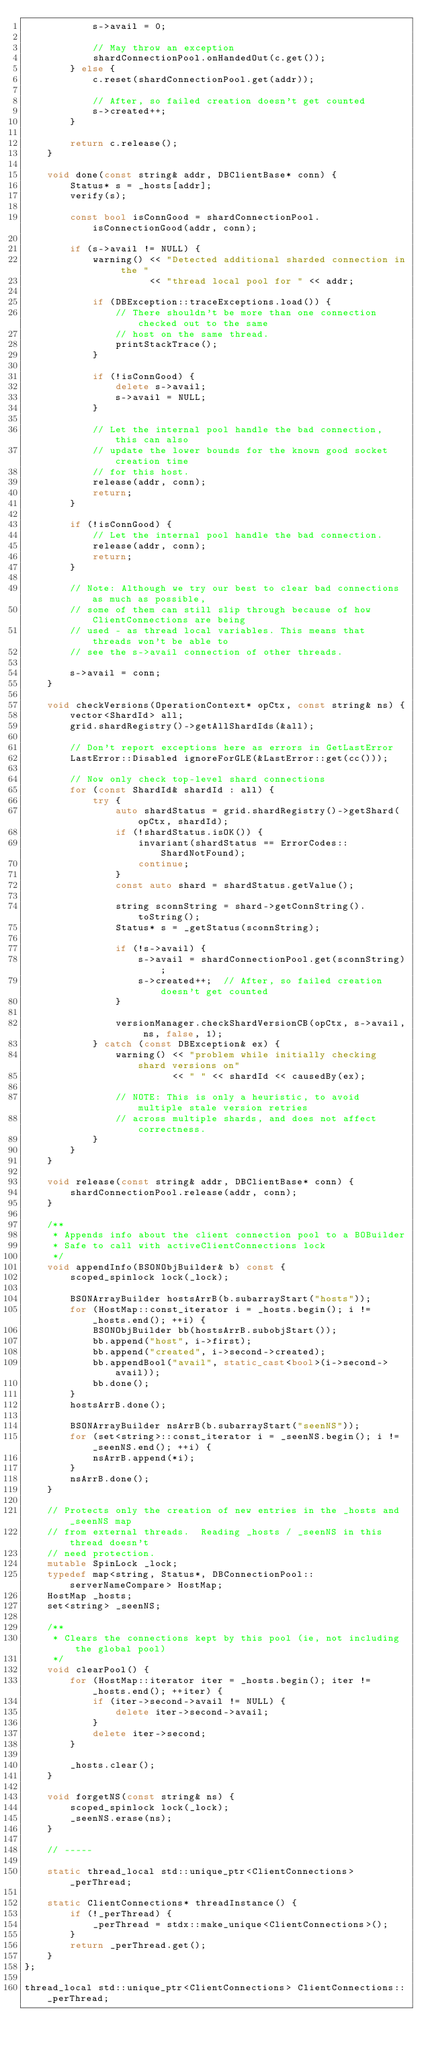Convert code to text. <code><loc_0><loc_0><loc_500><loc_500><_C++_>            s->avail = 0;

            // May throw an exception
            shardConnectionPool.onHandedOut(c.get());
        } else {
            c.reset(shardConnectionPool.get(addr));

            // After, so failed creation doesn't get counted
            s->created++;
        }

        return c.release();
    }

    void done(const string& addr, DBClientBase* conn) {
        Status* s = _hosts[addr];
        verify(s);

        const bool isConnGood = shardConnectionPool.isConnectionGood(addr, conn);

        if (s->avail != NULL) {
            warning() << "Detected additional sharded connection in the "
                      << "thread local pool for " << addr;

            if (DBException::traceExceptions.load()) {
                // There shouldn't be more than one connection checked out to the same
                // host on the same thread.
                printStackTrace();
            }

            if (!isConnGood) {
                delete s->avail;
                s->avail = NULL;
            }

            // Let the internal pool handle the bad connection, this can also
            // update the lower bounds for the known good socket creation time
            // for this host.
            release(addr, conn);
            return;
        }

        if (!isConnGood) {
            // Let the internal pool handle the bad connection.
            release(addr, conn);
            return;
        }

        // Note: Although we try our best to clear bad connections as much as possible,
        // some of them can still slip through because of how ClientConnections are being
        // used - as thread local variables. This means that threads won't be able to
        // see the s->avail connection of other threads.

        s->avail = conn;
    }

    void checkVersions(OperationContext* opCtx, const string& ns) {
        vector<ShardId> all;
        grid.shardRegistry()->getAllShardIds(&all);

        // Don't report exceptions here as errors in GetLastError
        LastError::Disabled ignoreForGLE(&LastError::get(cc()));

        // Now only check top-level shard connections
        for (const ShardId& shardId : all) {
            try {
                auto shardStatus = grid.shardRegistry()->getShard(opCtx, shardId);
                if (!shardStatus.isOK()) {
                    invariant(shardStatus == ErrorCodes::ShardNotFound);
                    continue;
                }
                const auto shard = shardStatus.getValue();

                string sconnString = shard->getConnString().toString();
                Status* s = _getStatus(sconnString);

                if (!s->avail) {
                    s->avail = shardConnectionPool.get(sconnString);
                    s->created++;  // After, so failed creation doesn't get counted
                }

                versionManager.checkShardVersionCB(opCtx, s->avail, ns, false, 1);
            } catch (const DBException& ex) {
                warning() << "problem while initially checking shard versions on"
                          << " " << shardId << causedBy(ex);

                // NOTE: This is only a heuristic, to avoid multiple stale version retries
                // across multiple shards, and does not affect correctness.
            }
        }
    }

    void release(const string& addr, DBClientBase* conn) {
        shardConnectionPool.release(addr, conn);
    }

    /**
     * Appends info about the client connection pool to a BOBuilder
     * Safe to call with activeClientConnections lock
     */
    void appendInfo(BSONObjBuilder& b) const {
        scoped_spinlock lock(_lock);

        BSONArrayBuilder hostsArrB(b.subarrayStart("hosts"));
        for (HostMap::const_iterator i = _hosts.begin(); i != _hosts.end(); ++i) {
            BSONObjBuilder bb(hostsArrB.subobjStart());
            bb.append("host", i->first);
            bb.append("created", i->second->created);
            bb.appendBool("avail", static_cast<bool>(i->second->avail));
            bb.done();
        }
        hostsArrB.done();

        BSONArrayBuilder nsArrB(b.subarrayStart("seenNS"));
        for (set<string>::const_iterator i = _seenNS.begin(); i != _seenNS.end(); ++i) {
            nsArrB.append(*i);
        }
        nsArrB.done();
    }

    // Protects only the creation of new entries in the _hosts and _seenNS map
    // from external threads.  Reading _hosts / _seenNS in this thread doesn't
    // need protection.
    mutable SpinLock _lock;
    typedef map<string, Status*, DBConnectionPool::serverNameCompare> HostMap;
    HostMap _hosts;
    set<string> _seenNS;

    /**
     * Clears the connections kept by this pool (ie, not including the global pool)
     */
    void clearPool() {
        for (HostMap::iterator iter = _hosts.begin(); iter != _hosts.end(); ++iter) {
            if (iter->second->avail != NULL) {
                delete iter->second->avail;
            }
            delete iter->second;
        }

        _hosts.clear();
    }

    void forgetNS(const string& ns) {
        scoped_spinlock lock(_lock);
        _seenNS.erase(ns);
    }

    // -----

    static thread_local std::unique_ptr<ClientConnections> _perThread;

    static ClientConnections* threadInstance() {
        if (!_perThread) {
            _perThread = stdx::make_unique<ClientConnections>();
        }
        return _perThread.get();
    }
};

thread_local std::unique_ptr<ClientConnections> ClientConnections::_perThread;
</code> 